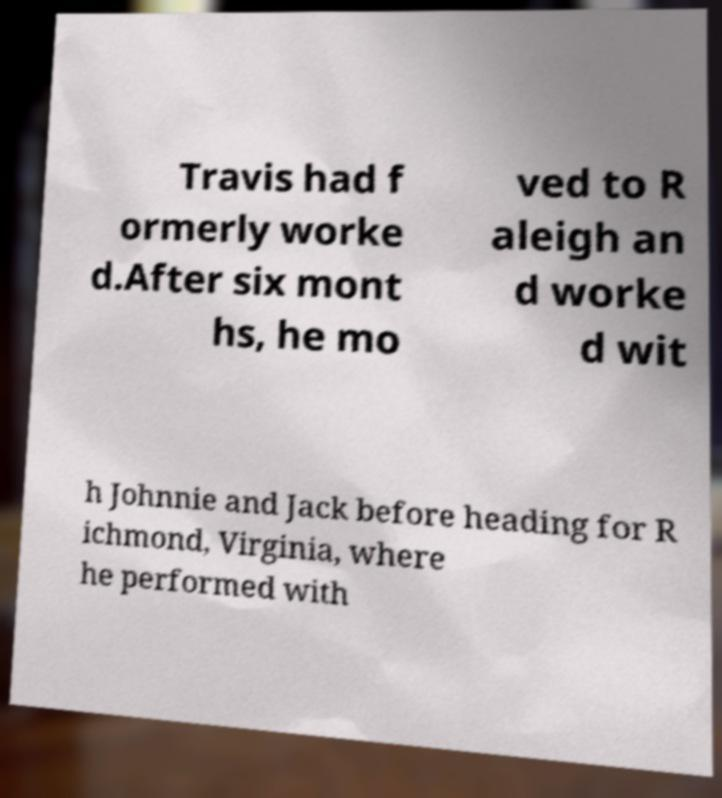For documentation purposes, I need the text within this image transcribed. Could you provide that? Travis had f ormerly worke d.After six mont hs, he mo ved to R aleigh an d worke d wit h Johnnie and Jack before heading for R ichmond, Virginia, where he performed with 